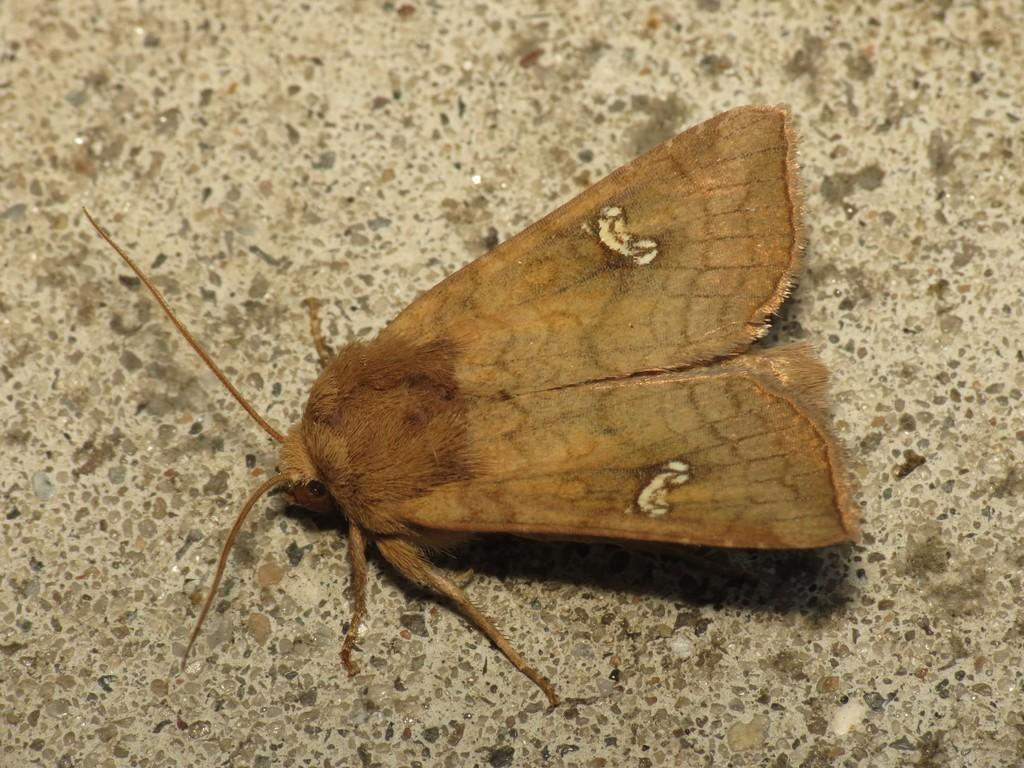What type of creature can be seen in the image? There is an insect in the image. Where is the insect located? The insect is on a surface. Is there a parcel being delivered by the insect in the image? No, there is no parcel present in the image, and the insect is not delivering anything. 